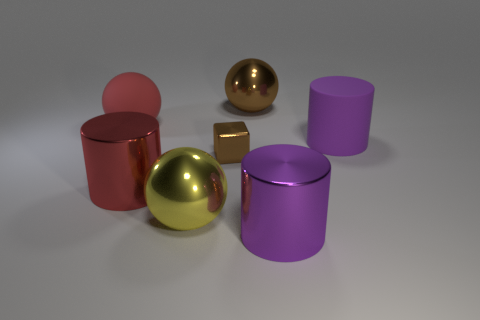The big object that is the same color as the tiny block is what shape?
Provide a succinct answer. Sphere. Does the red object that is in front of the tiny brown metal thing have the same shape as the big rubber object right of the big red cylinder?
Your answer should be compact. Yes. Is the number of big yellow metallic spheres that are behind the big yellow shiny object the same as the number of red metal cylinders?
Offer a very short reply. No. Is there a big thing in front of the purple object that is on the right side of the big purple shiny thing?
Your answer should be very brief. Yes. Are there any other things that have the same color as the matte ball?
Your answer should be very brief. Yes. Are the large red thing that is left of the big red metal cylinder and the brown sphere made of the same material?
Offer a very short reply. No. Is the number of large red things that are on the right side of the matte cylinder the same as the number of red metallic cylinders that are in front of the tiny brown object?
Offer a terse response. No. There is a purple cylinder in front of the shiny cylinder that is to the left of the large brown thing; what is its size?
Provide a short and direct response. Large. There is a cylinder that is behind the big yellow shiny object and in front of the tiny block; what is its material?
Your answer should be very brief. Metal. How many other objects are there of the same size as the purple matte thing?
Your response must be concise. 5. 